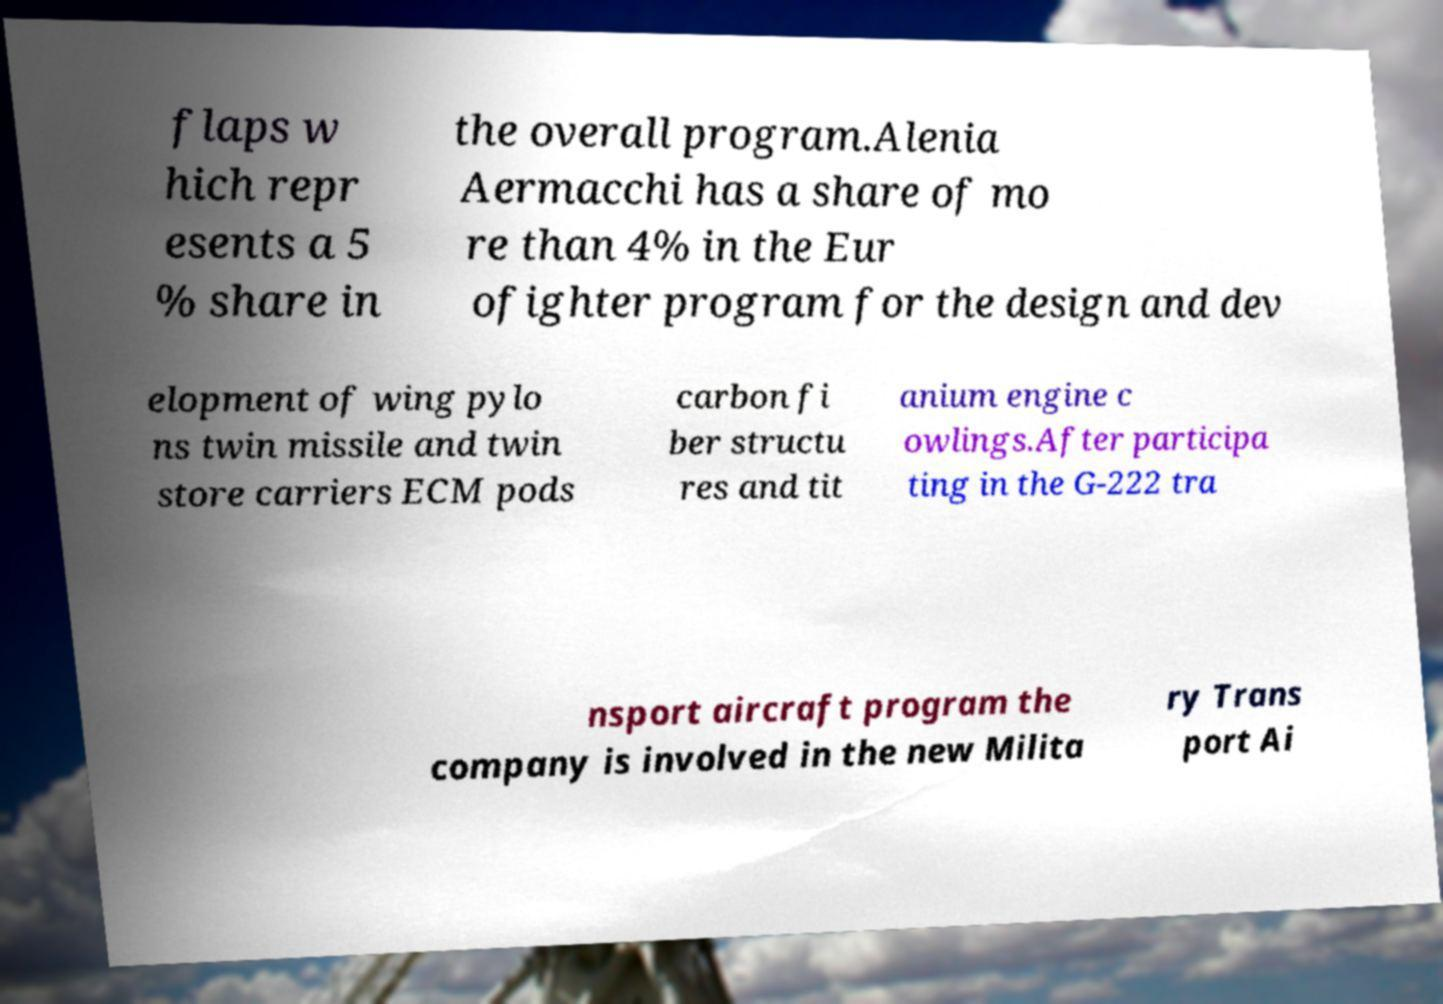I need the written content from this picture converted into text. Can you do that? flaps w hich repr esents a 5 % share in the overall program.Alenia Aermacchi has a share of mo re than 4% in the Eur ofighter program for the design and dev elopment of wing pylo ns twin missile and twin store carriers ECM pods carbon fi ber structu res and tit anium engine c owlings.After participa ting in the G-222 tra nsport aircraft program the company is involved in the new Milita ry Trans port Ai 